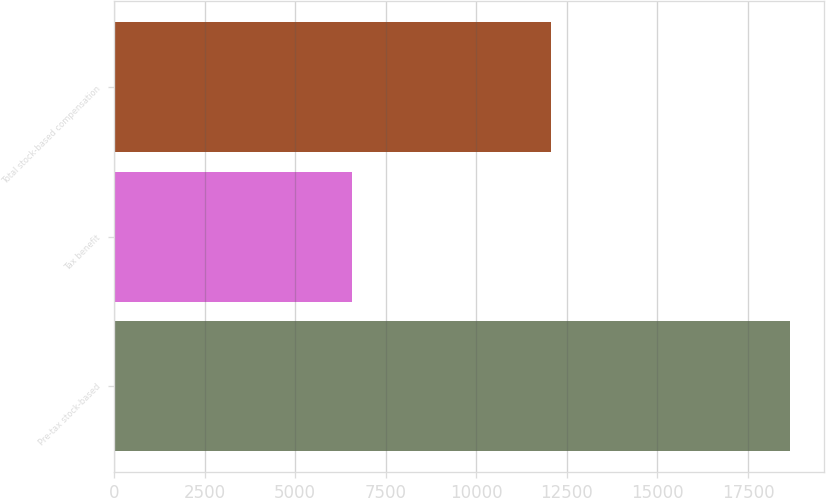Convert chart to OTSL. <chart><loc_0><loc_0><loc_500><loc_500><bar_chart><fcel>Pre-tax stock-based<fcel>Tax benefit<fcel>Total stock-based compensation<nl><fcel>18650<fcel>6579<fcel>12071<nl></chart> 